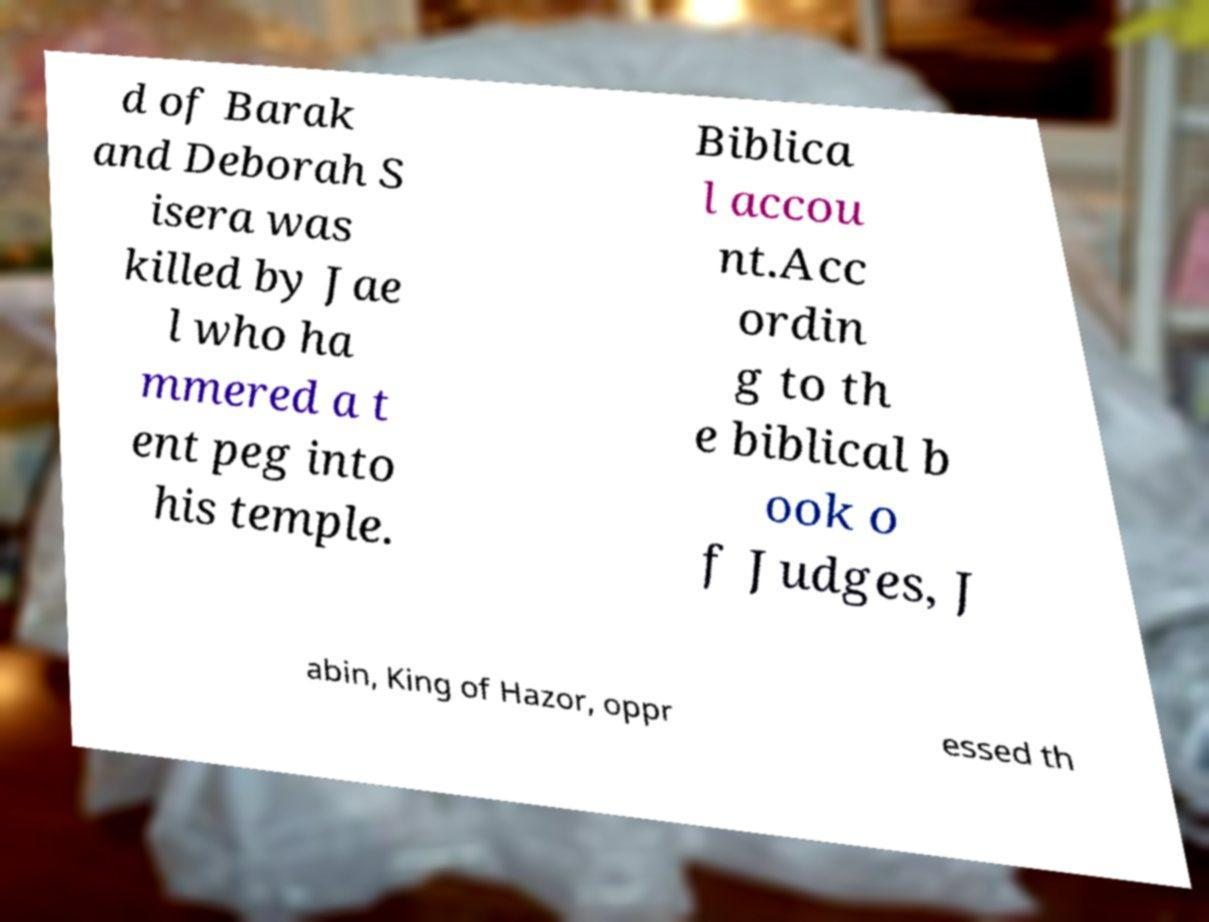There's text embedded in this image that I need extracted. Can you transcribe it verbatim? d of Barak and Deborah S isera was killed by Jae l who ha mmered a t ent peg into his temple. Biblica l accou nt.Acc ordin g to th e biblical b ook o f Judges, J abin, King of Hazor, oppr essed th 